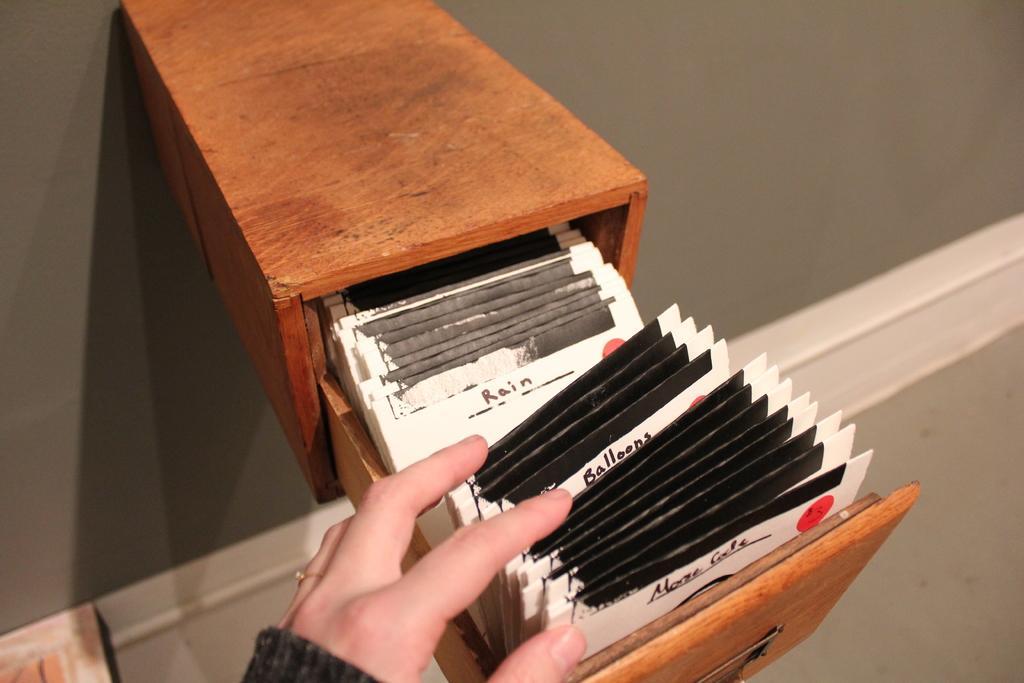Can you describe this image briefly? In this image we can see box with drawer attached to the wall. Inside the box there are packets. Also we can see hand of a person. 